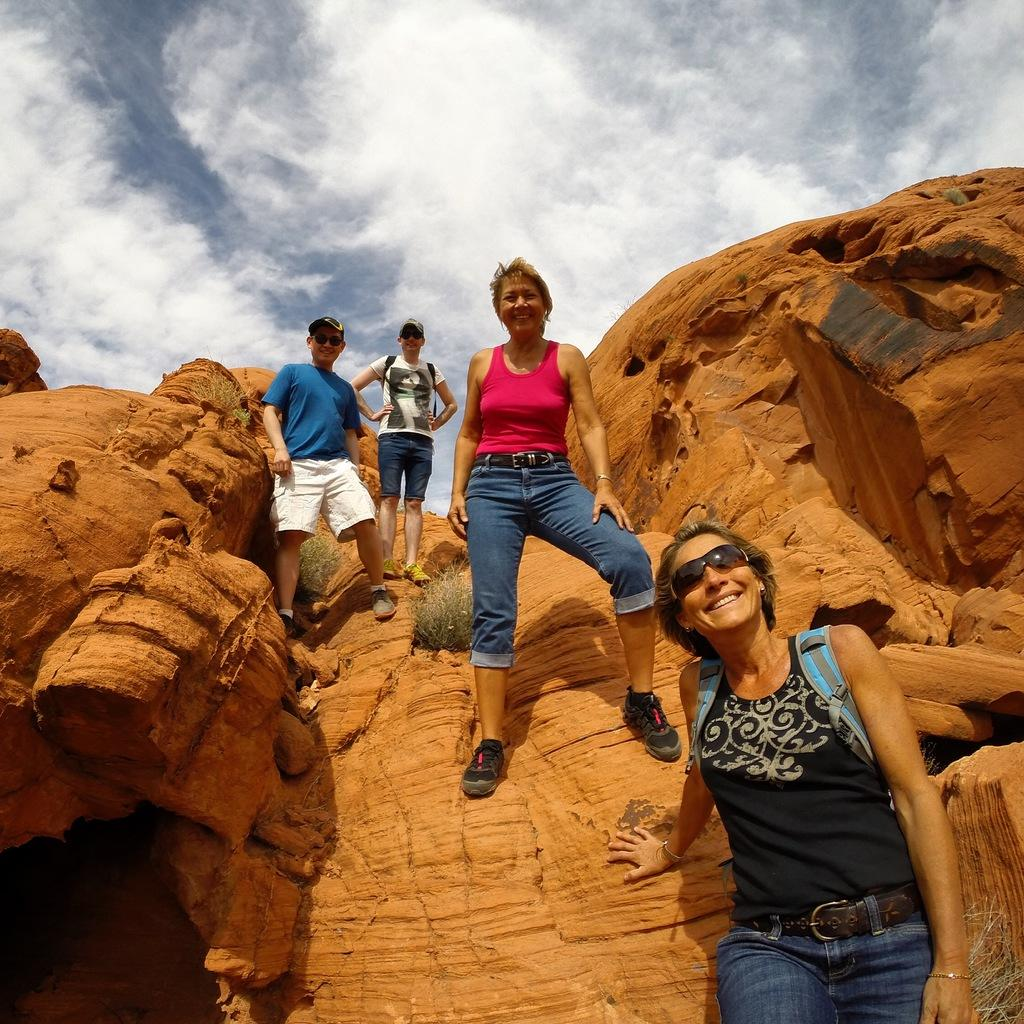How many people are in the image? There are people in the image, but the exact number is not specified. What are the people standing on? The people are standing on rocks. What type of tub is visible in the image? There is no tub present in the image. 